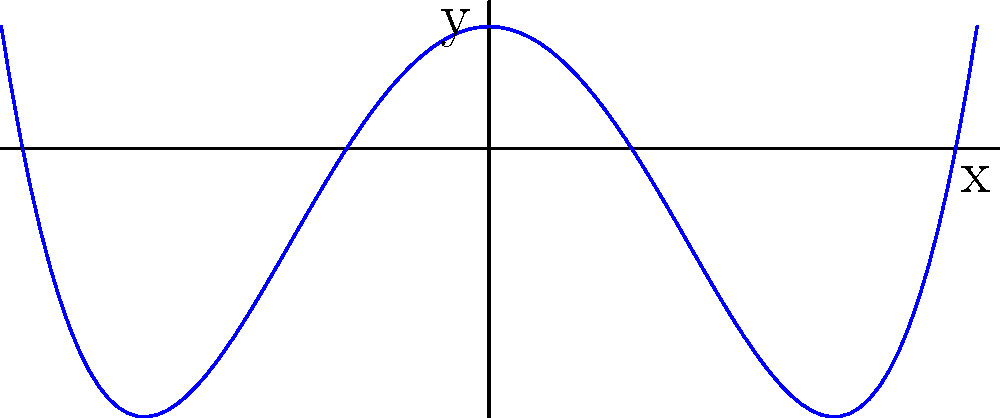The graph above represents a polynomial function. Based on the shape and behavior of this graph, what is the degree of the polynomial? To determine the degree of a polynomial from its graph, we need to consider the following steps:

1. Observe the end behavior: As $x$ approaches positive or negative infinity, how does the $y$-value behave?
   In this case, both ends of the graph go upward as $x$ increases or decreases.

2. Count the turning points: How many times does the graph change direction?
   This graph has 3 turning points: two local minima and one local maximum.

3. Apply the degree rules:
   - A polynomial of degree $n$ can have at most $n-1$ turning points.
   - The end behavior of even-degree polynomials is the same on both ends (both up or both down).
   - The end behavior of odd-degree polynomials is opposite on each end (one up, one down).

4. Conclude:
   - The graph has 3 turning points, so the degree must be at least 4.
   - Both ends of the graph go upward, indicating an even degree.
   - The simplest polynomial satisfying these conditions is of degree 4.

Therefore, the degree of this polynomial is 4.
Answer: 4 